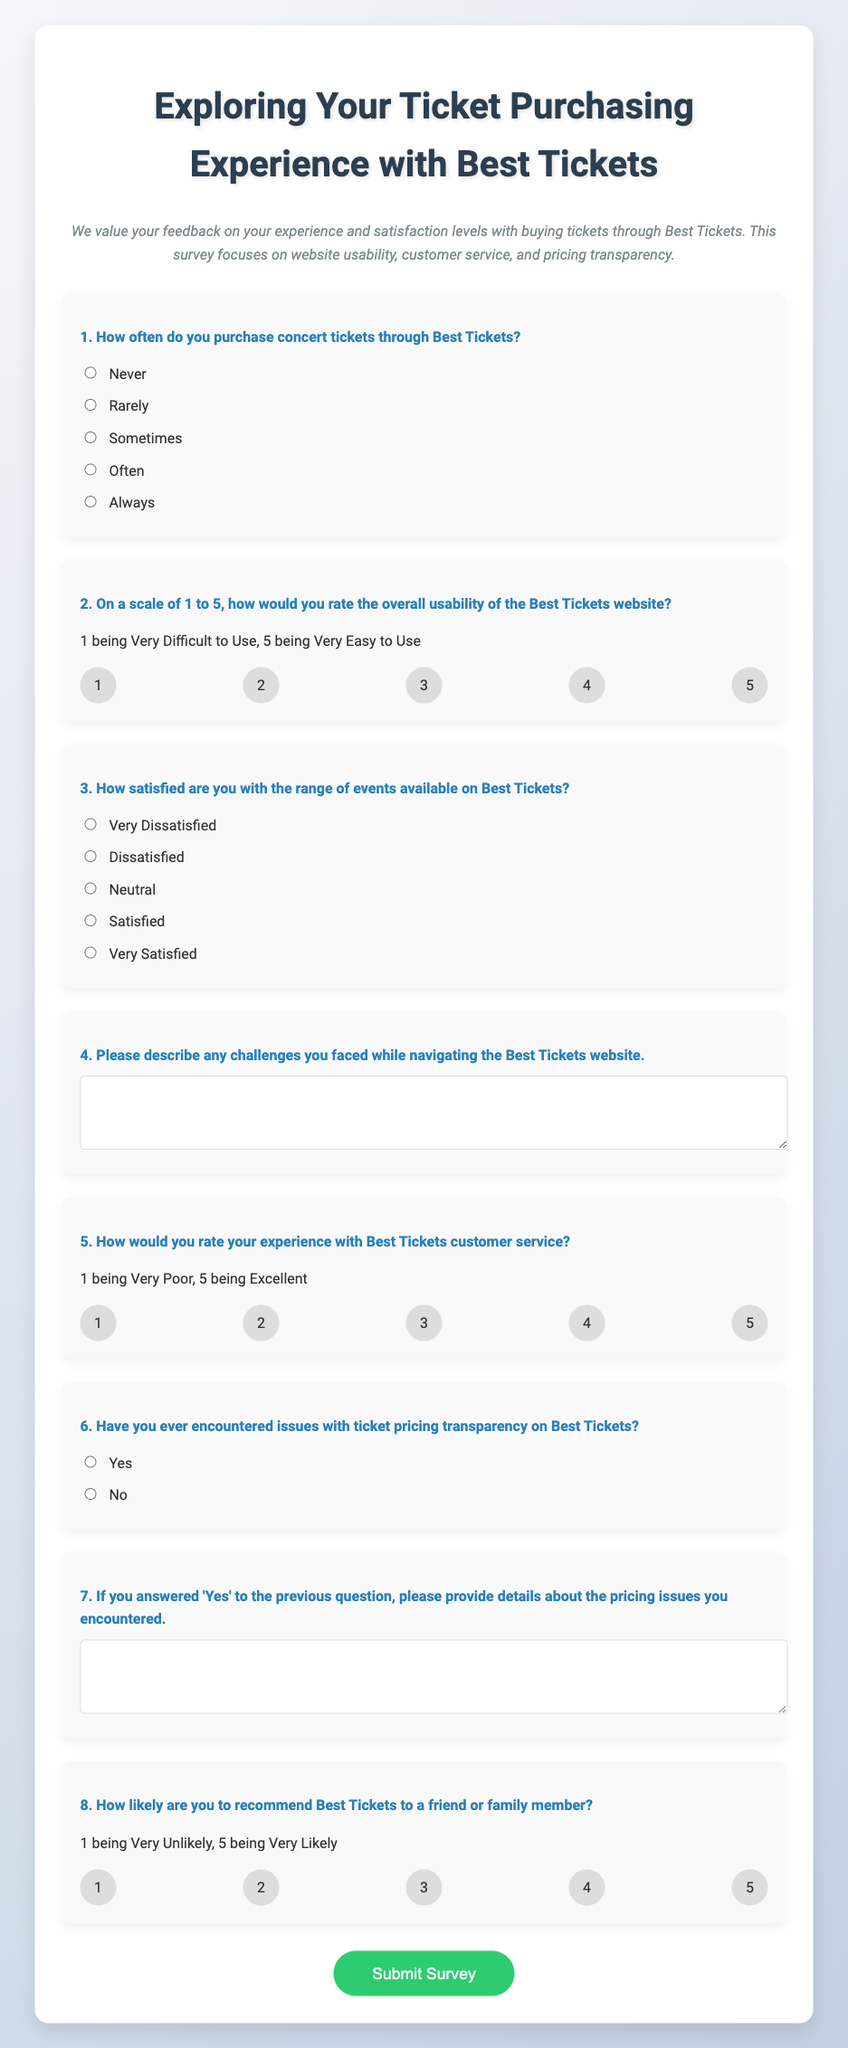What is the title of the survey? The title of the survey is prominently displayed at the top of the document, stating "Exploring Your Ticket Purchasing Experience with Best Tickets."
Answer: Exploring Your Ticket Purchasing Experience with Best Tickets How many questions are there in the survey? The document consists of a total of eight questions for participants to answer.
Answer: Eight What is the scale used to rate website usability? The survey uses a scale from 1 to 5, where 1 is "Very Difficult to Use" and 5 is "Very Easy to Use."
Answer: 1 to 5 What option corresponds to the highest satisfaction level for event range? The highest satisfaction level for the range of events available is indicated by the option "Very Satisfied."
Answer: Very Satisfied What does the submit button say? The submit button at the end of the survey is labeled for participants to finalize their input.
Answer: Submit Survey What is the condition for providing details about pricing issues? Participants are asked to provide details about pricing issues only if they selected 'Yes' in the previous question regarding pricing transparency.
Answer: If 'Yes' is selected How is customer service experience rated? Customer service experience is rated on a scale of 1 to 5, where 1 indicates "Very Poor" and 5 indicates "Excellent."
Answer: 1 to 5 How likely are participants to recommend Best Tickets? Participants rate their likelihood of recommending Best Tickets on a scale of 1 to 5, where 1 is "Very Unlikely."
Answer: 1 to 5 